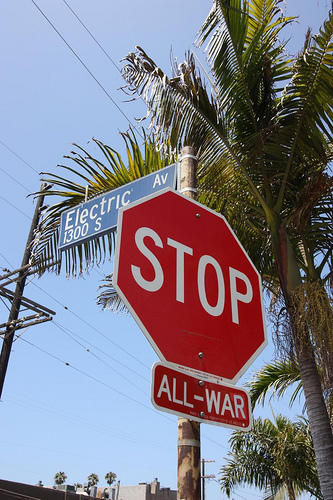Please extract the text content from this image. STOP Electric 1300 S AV ALL WAR 